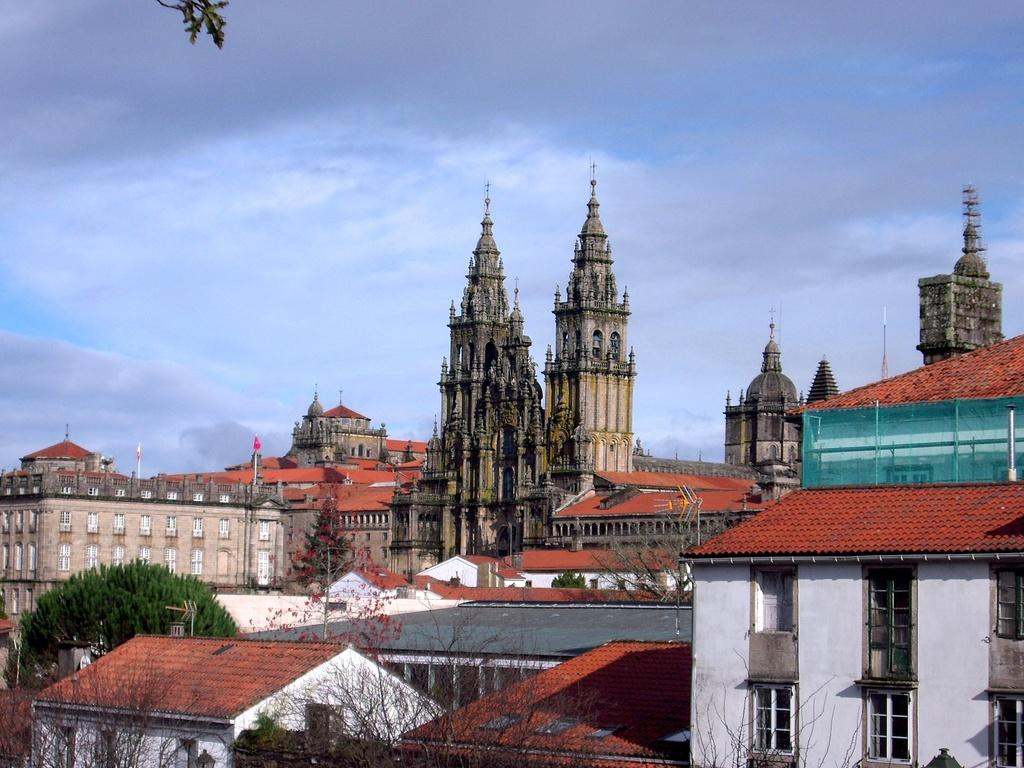What types of structures are visible in the image? There are buildings and houses in the image. What natural elements can be seen in the image? There are trees, plants, and flowers in the image. What song is being sung by the cloth in the image? There is no cloth or singing in the image; it features buildings, houses, trees, plants, and flowers. 